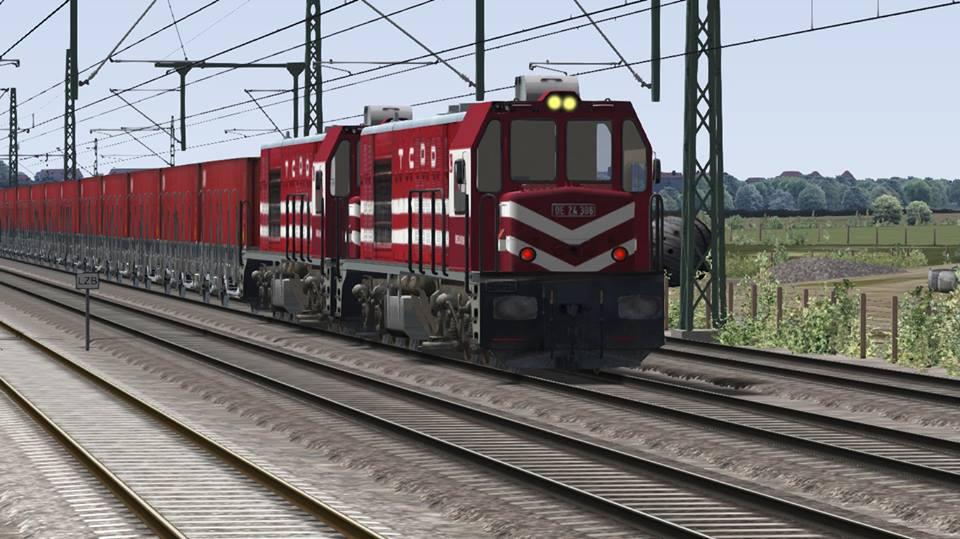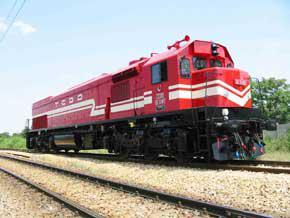The first image is the image on the left, the second image is the image on the right. Given the left and right images, does the statement "Both images have trains facing towards the right." hold true? Answer yes or no. Yes. The first image is the image on the left, the second image is the image on the right. For the images displayed, is the sentence "One train contains the three colors red, white, and blue on the main body." factually correct? Answer yes or no. No. 